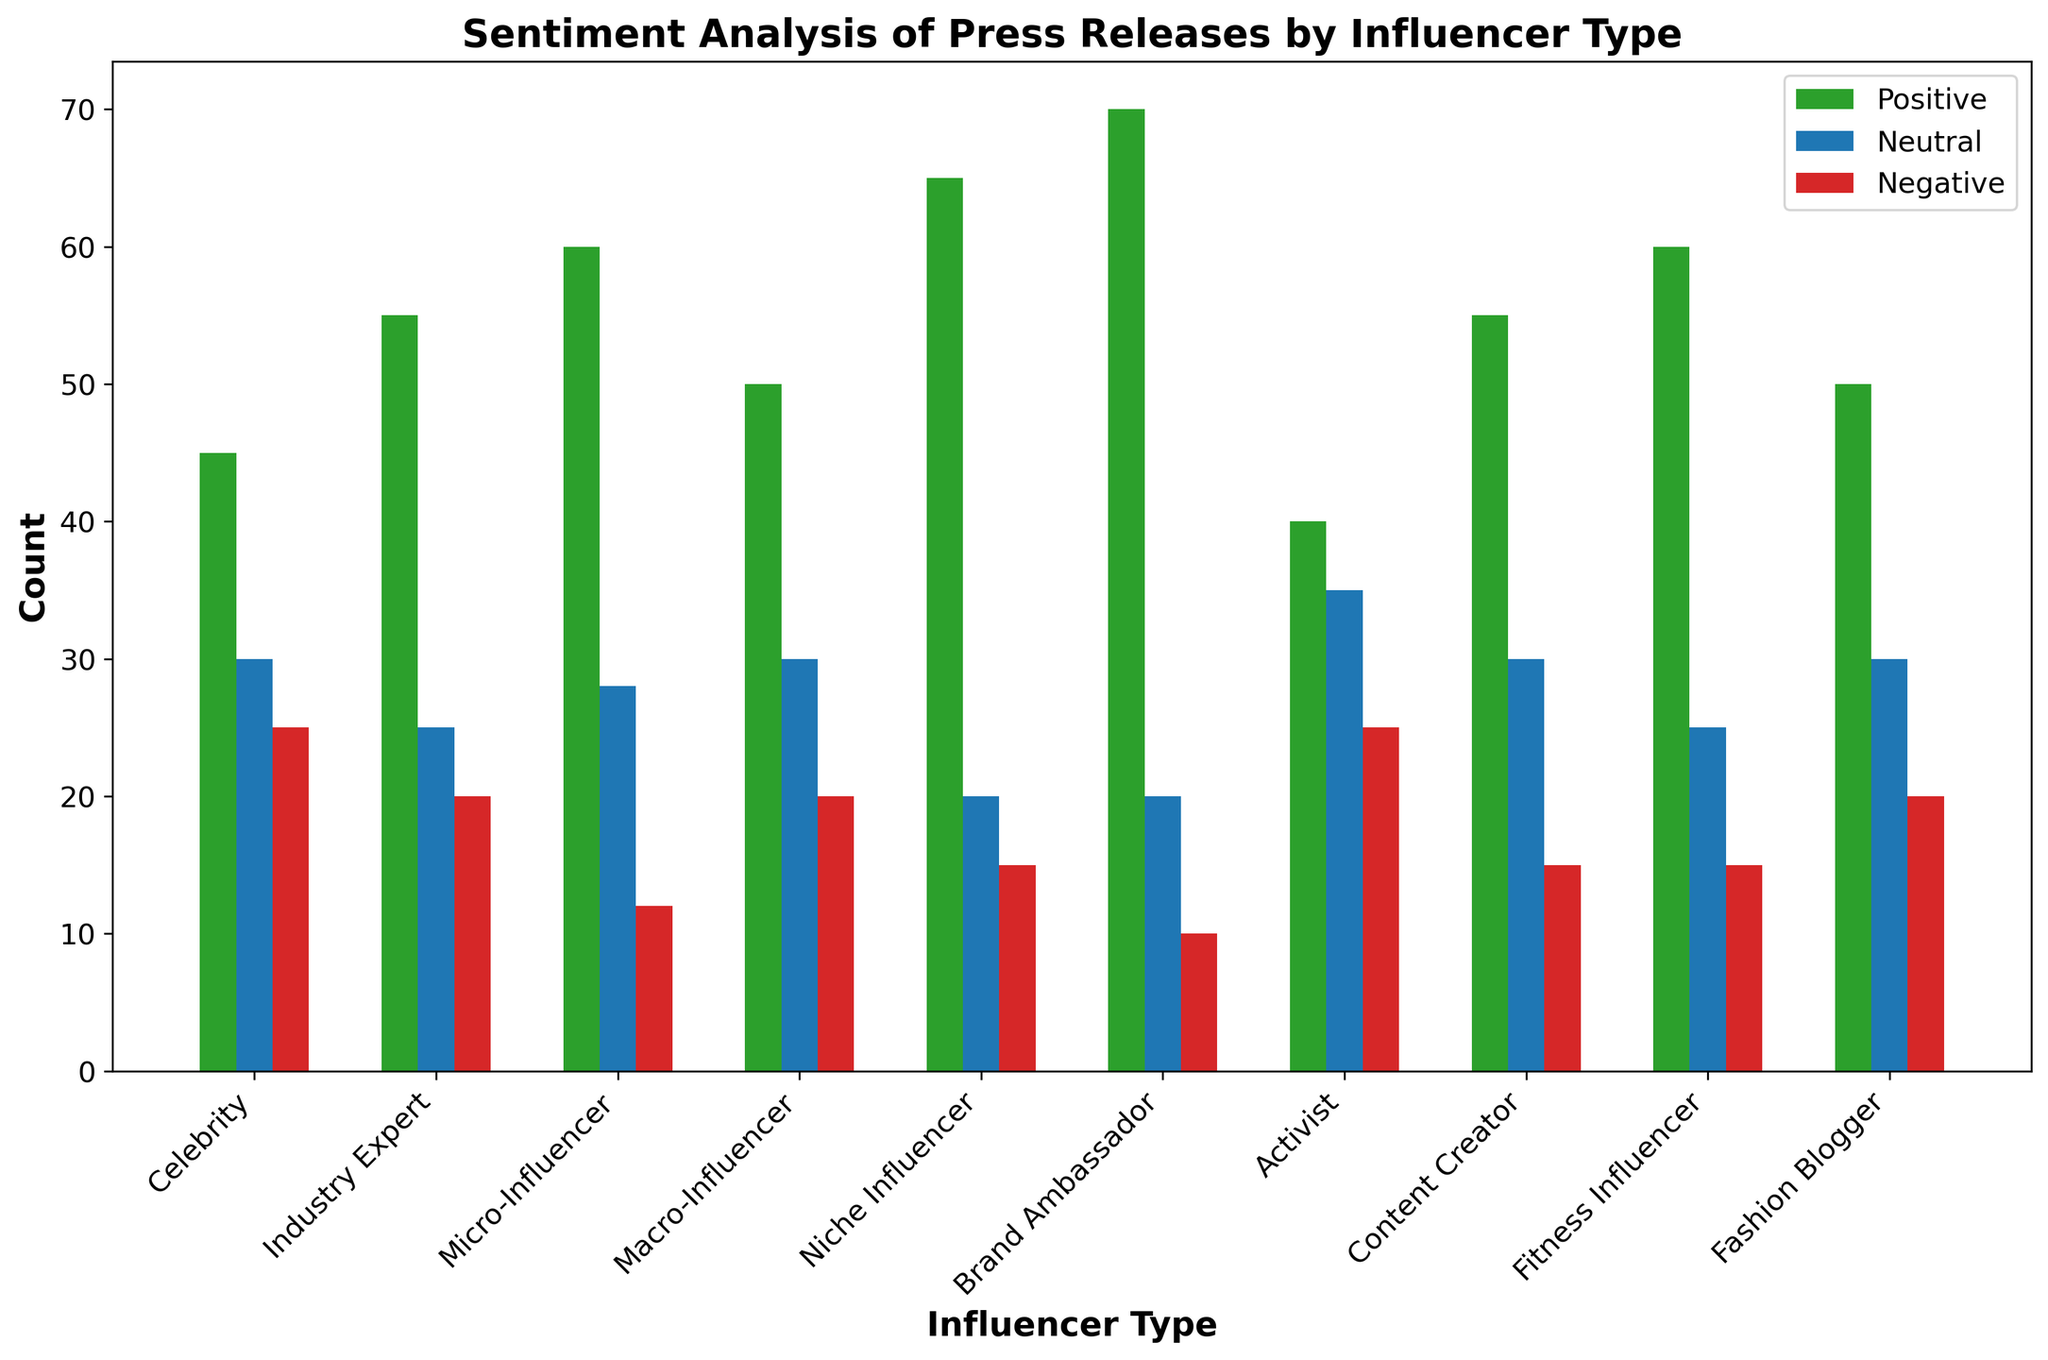What is the average number of positive sentiments across all influencer types? First, sum the positive sentiments: 45 + 55 + 60 + 50 + 65 + 70 + 40 + 55 + 60 + 50 = 550. There are 10 influencer types, so the average is 550 / 10 = 55.
Answer: 55 Which influencer type has the highest number of positive sentiments? By looking at the heights of the green bars for positive sentiments, the Brand Ambassador has the highest count with 70.
Answer: Brand Ambassador What is the difference between the number of positive and negative sentiments for Niche Influencers? Niche Influencers have 65 positive and 15 negative sentiments. The difference is 65 - 15 = 50.
Answer: 50 Which influencer type has the most neutral sentiments, and what is that number? By observing the heights of the blue bars for neutral sentiments, Activists have the most with 35.
Answer: Activist, 35 How does the number of negative sentiments for Celebrity Influencers compare to the number of positive sentiments for Fitness Influencers? Celebrity Influencers have 25 negative sentiments, and Fitness Influencers have 60 positive sentiments. So, Fitness Influencers have more by 60 - 25 = 35.
Answer: Fitness Influencers have 35 more sentiments What is the total number of sentiments (positive, neutral, and negative) for Content Creators? Sum the counts for Content Creators: 55 (positive) + 30 (neutral) + 15 (negative) = 100.
Answer: 100 Which influencer types have negative sentiments greater than their neutral sentiments? By comparing the red and blue bars, only Activists and Celebrities have more negative sentiments (25 and 25, respectively) than neutral sentiments (both 30).
Answer: Activist, Celebrity What is the combined number of neutral and negative sentiments for Micro-Influencers? Add the neutral and negative sentiments for Micro-Influencers: 28 (neutral) + 12 (negative) = 40.
Answer: 40 Which influencer type has the smallest range of sentiment counts? The range of sentiments is calculated by the difference between the highest and lowest sentiment counts for each influencer type. Niche Influencers have a range of 65 (positive) - 15 (negative) = 50, which is the smallest.
Answer: Niche Influencer What is the median number of neutral sentiments across all influencer types? Arrange the neutral sentiment counts in ascending order: [20, 20, 20, 25, 25, 28, 30, 30, 30, 35]. The median is the average of the fifth and sixth values: (25 + 28) / 2 = 26.5.
Answer: 26.5 